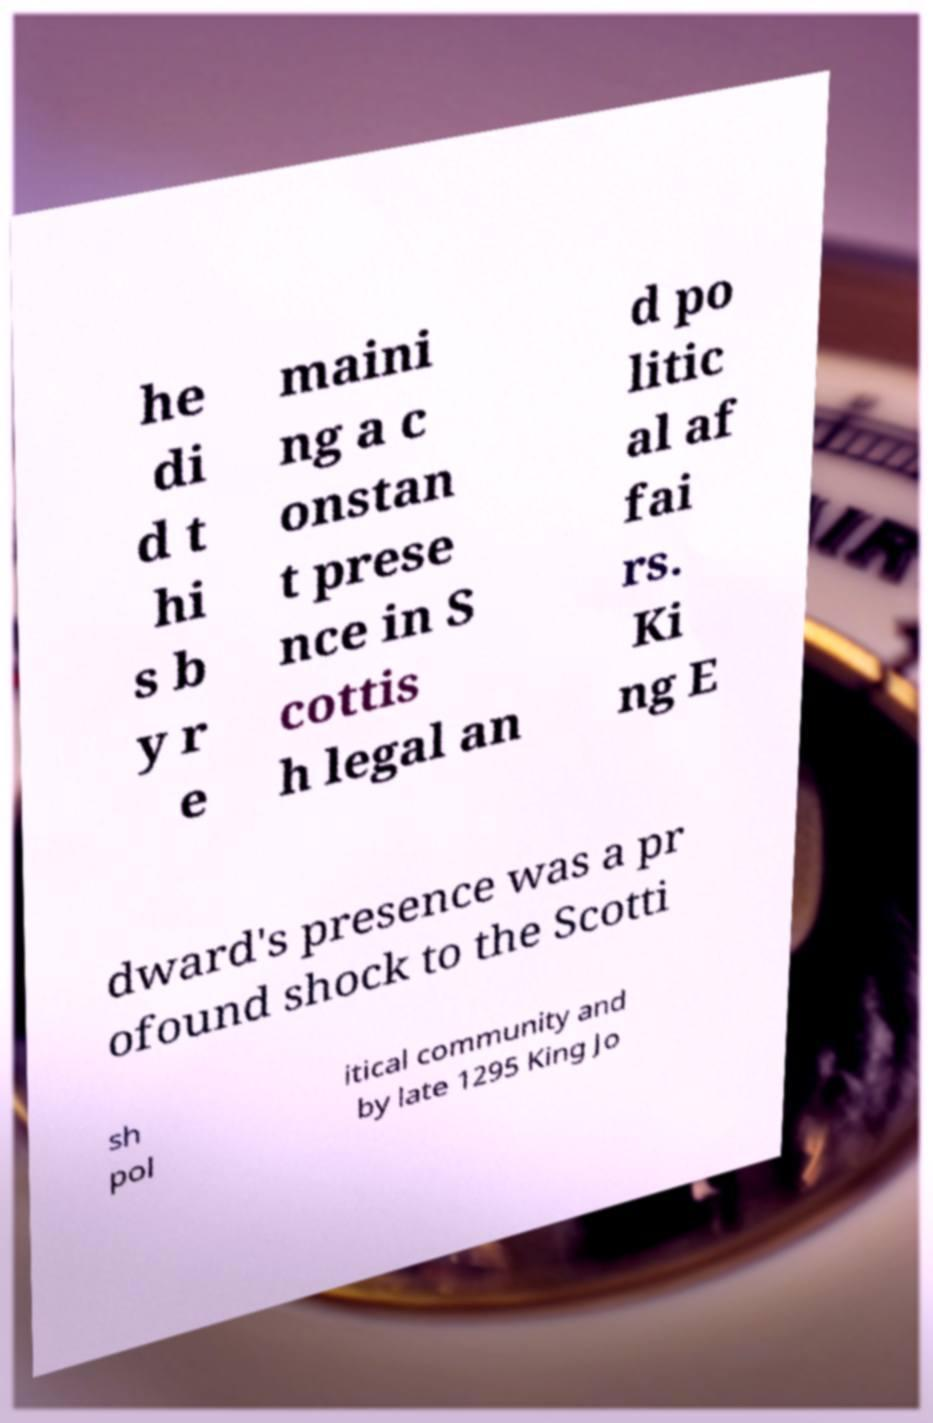Please read and relay the text visible in this image. What does it say? he di d t hi s b y r e maini ng a c onstan t prese nce in S cottis h legal an d po litic al af fai rs. Ki ng E dward's presence was a pr ofound shock to the Scotti sh pol itical community and by late 1295 King Jo 